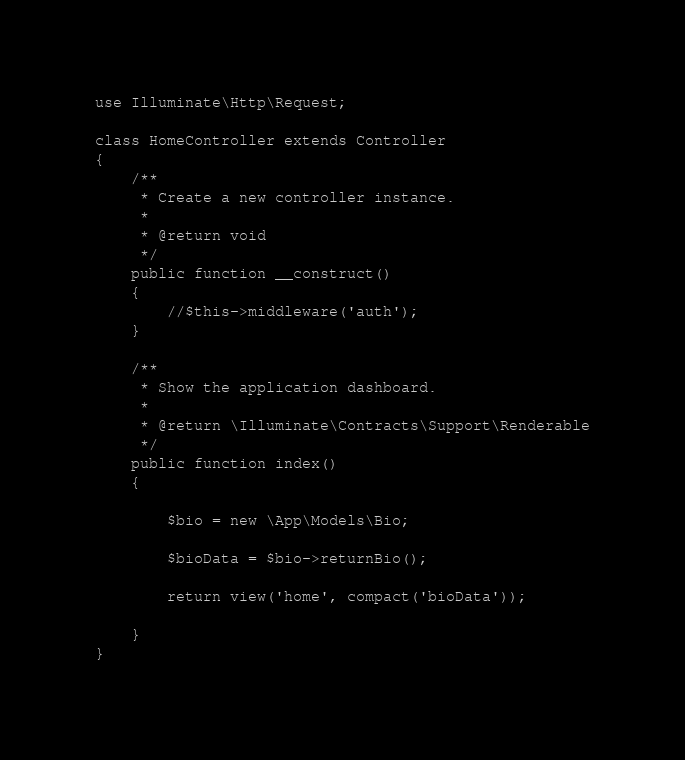<code> <loc_0><loc_0><loc_500><loc_500><_PHP_>use Illuminate\Http\Request;

class HomeController extends Controller
{
    /**
     * Create a new controller instance.
     *
     * @return void
     */
    public function __construct()
    {
        //$this->middleware('auth');
    }

    /**
     * Show the application dashboard.
     *
     * @return \Illuminate\Contracts\Support\Renderable
     */
    public function index()
    {
        
        $bio = new \App\Models\Bio;
        
        $bioData = $bio->returnBio();

        return view('home', compact('bioData'));

    }
}
</code> 